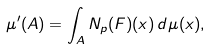Convert formula to latex. <formula><loc_0><loc_0><loc_500><loc_500>\mu ^ { \prime } ( A ) = \int _ { A } N _ { p } ( F ) ( x ) \, d \mu ( x ) ,</formula> 